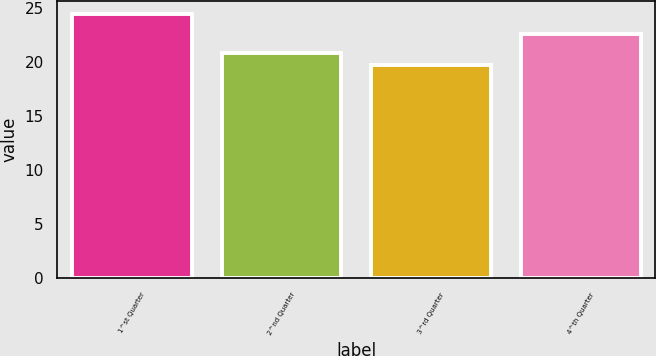Convert chart. <chart><loc_0><loc_0><loc_500><loc_500><bar_chart><fcel>1^st Quarter<fcel>2^nd Quarter<fcel>3^rd Quarter<fcel>4^th Quarter<nl><fcel>24.44<fcel>20.88<fcel>19.78<fcel>22.58<nl></chart> 